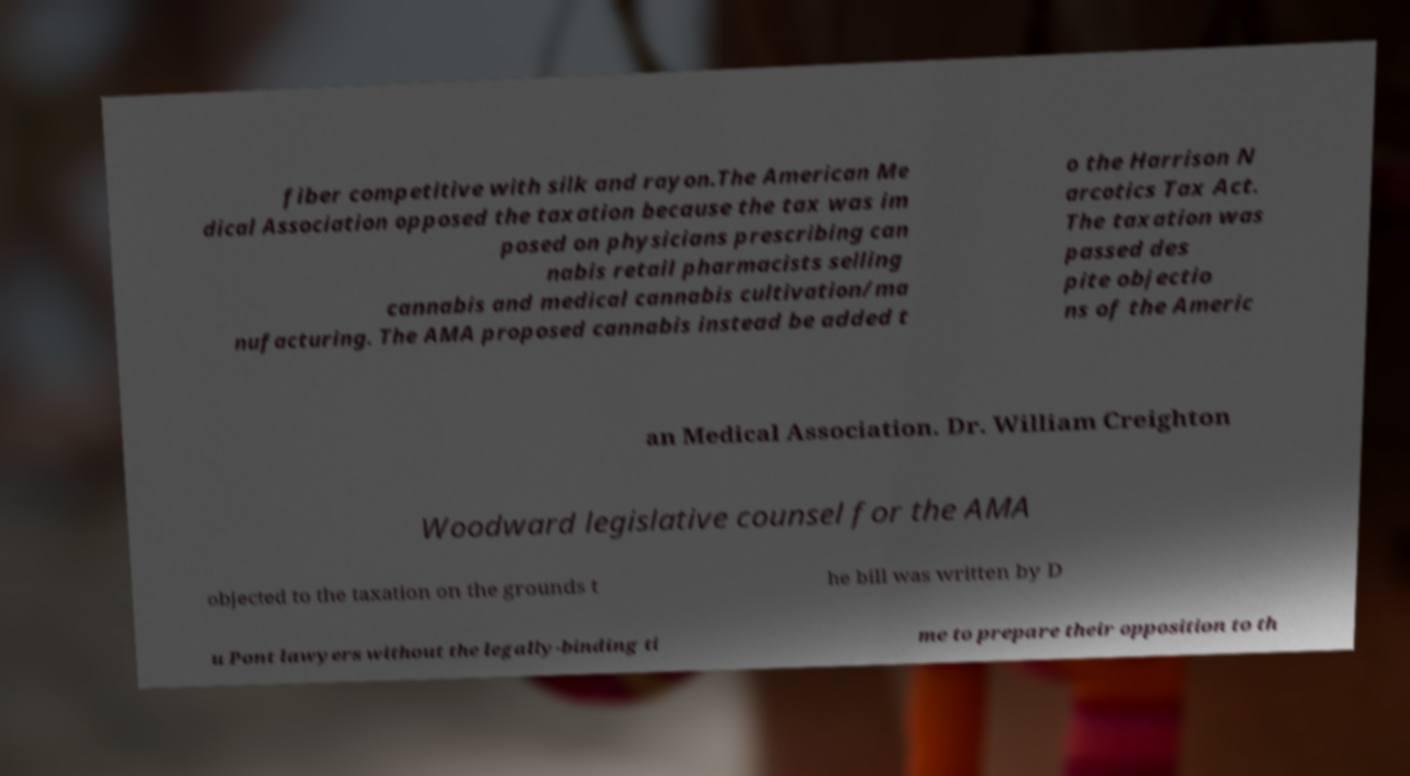Can you accurately transcribe the text from the provided image for me? fiber competitive with silk and rayon.The American Me dical Association opposed the taxation because the tax was im posed on physicians prescribing can nabis retail pharmacists selling cannabis and medical cannabis cultivation/ma nufacturing. The AMA proposed cannabis instead be added t o the Harrison N arcotics Tax Act. The taxation was passed des pite objectio ns of the Americ an Medical Association. Dr. William Creighton Woodward legislative counsel for the AMA objected to the taxation on the grounds t he bill was written by D u Pont lawyers without the legally-binding ti me to prepare their opposition to th 